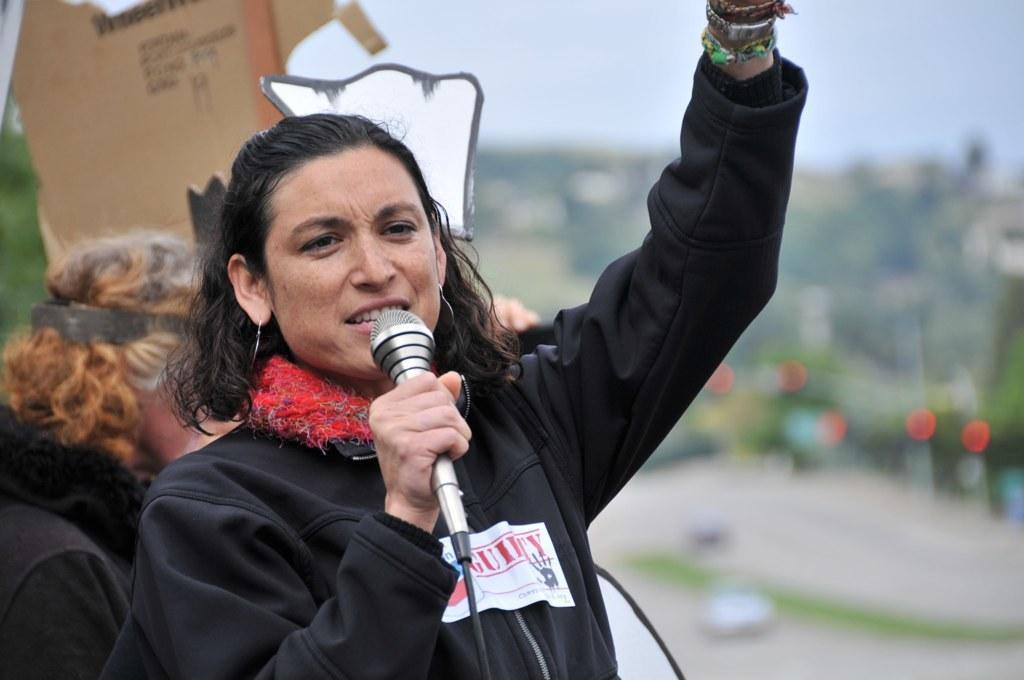Can you describe this image briefly? This Picture Describe about the woman delivering a speech holding a microphone in her hand and wearing a black jacket on which guilty is written. And Behind Her another woman is standing with brown color hair and wearing a black jacket. 